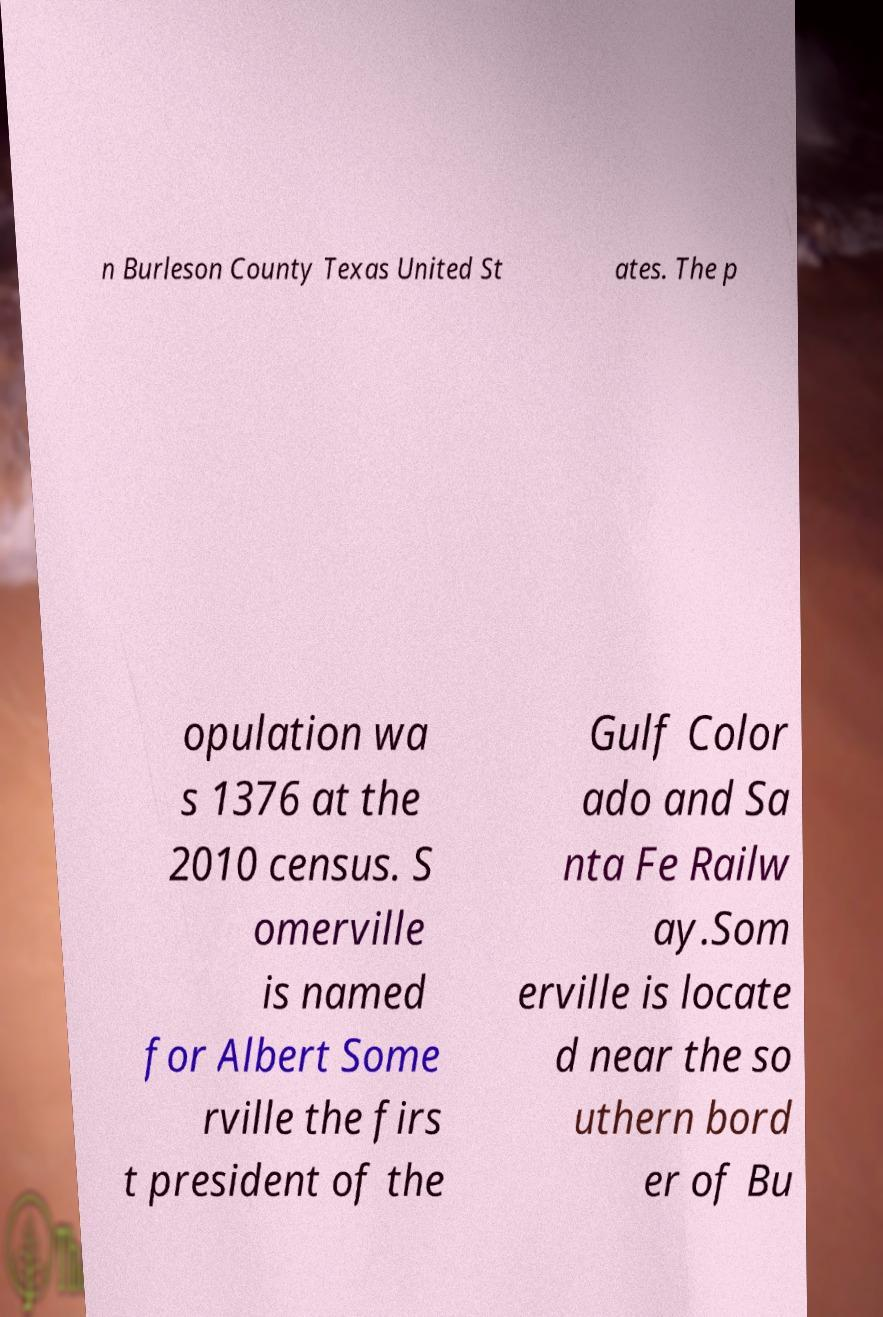I need the written content from this picture converted into text. Can you do that? n Burleson County Texas United St ates. The p opulation wa s 1376 at the 2010 census. S omerville is named for Albert Some rville the firs t president of the Gulf Color ado and Sa nta Fe Railw ay.Som erville is locate d near the so uthern bord er of Bu 